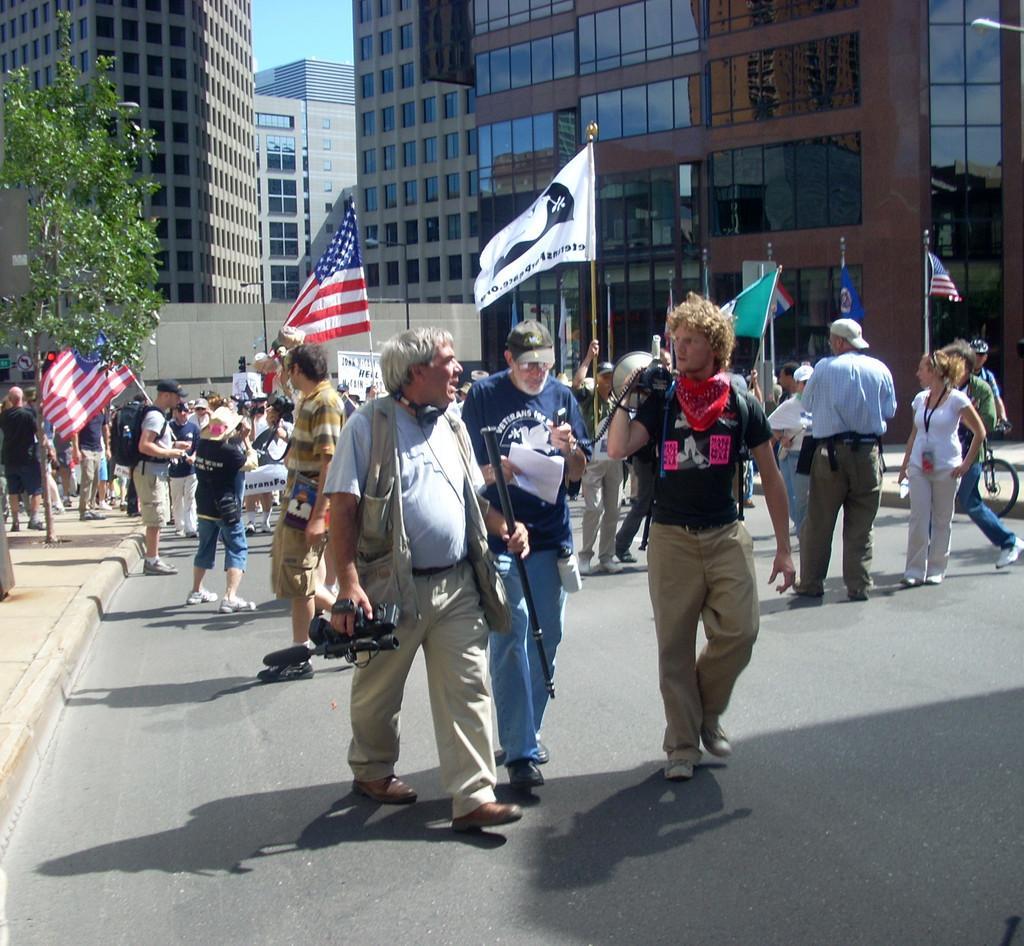How would you summarize this image in a sentence or two? In the middle of the image few people are standing and holding something in their hands and walking on the road. Behind them there are some trees and poles and flags and buildings. 